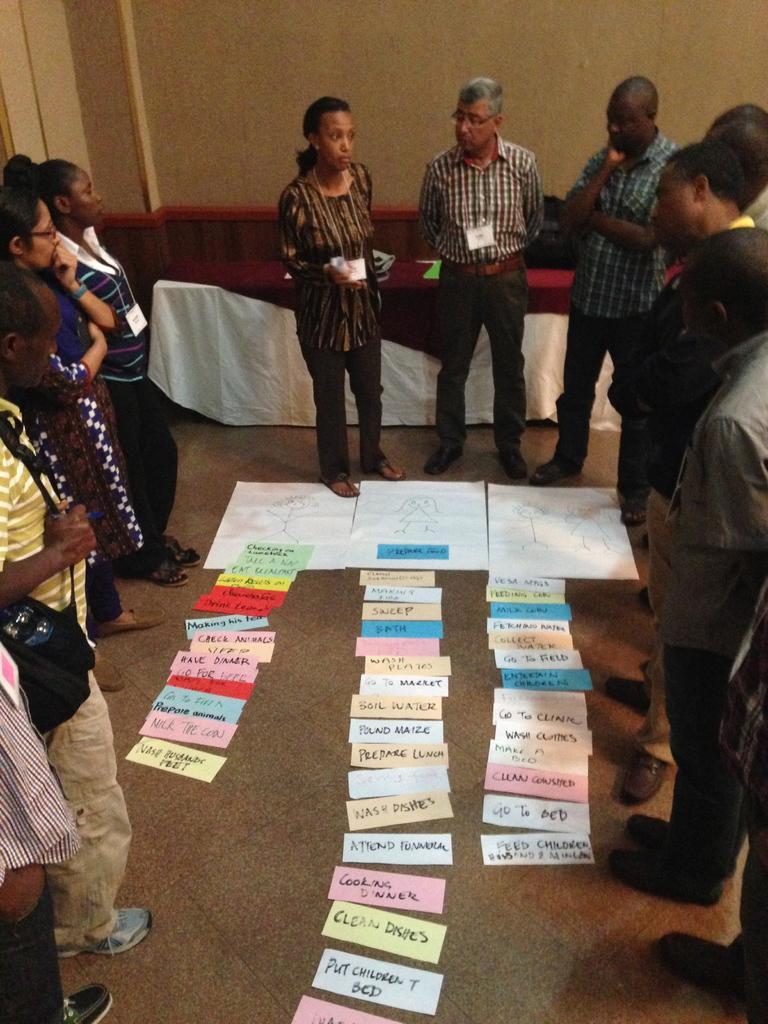Describe this image in one or two sentences. This picture shows few people standing and we see few of them were id cards and a man standing and he wore a backpack and holding with his hand and we see papers on the floor and we see a table on the back. 